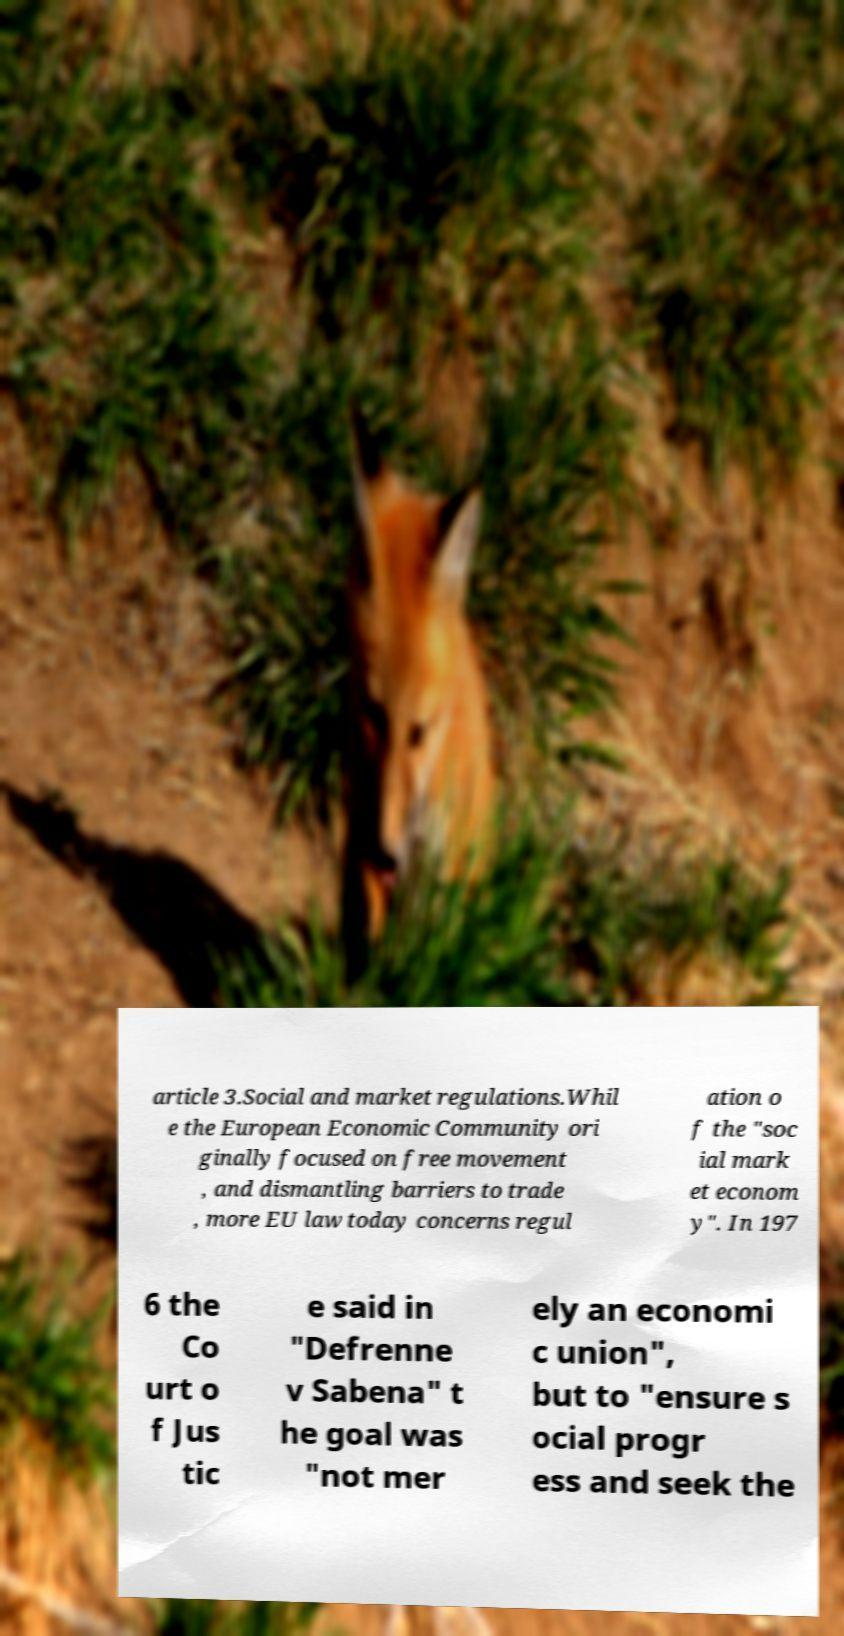Please identify and transcribe the text found in this image. article 3.Social and market regulations.Whil e the European Economic Community ori ginally focused on free movement , and dismantling barriers to trade , more EU law today concerns regul ation o f the "soc ial mark et econom y". In 197 6 the Co urt o f Jus tic e said in "Defrenne v Sabena" t he goal was "not mer ely an economi c union", but to "ensure s ocial progr ess and seek the 